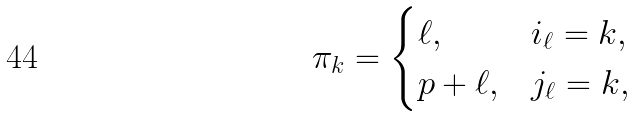Convert formula to latex. <formula><loc_0><loc_0><loc_500><loc_500>\pi _ { k } = \begin{cases} \ell , & i _ { \ell } = k , \\ p + \ell , & j _ { \ell } = k , \end{cases}</formula> 